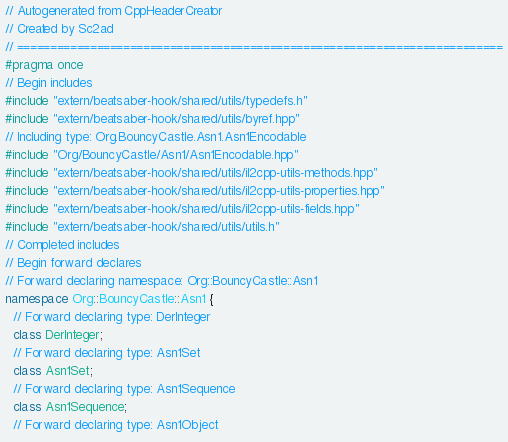Convert code to text. <code><loc_0><loc_0><loc_500><loc_500><_C++_>// Autogenerated from CppHeaderCreator
// Created by Sc2ad
// =========================================================================
#pragma once
// Begin includes
#include "extern/beatsaber-hook/shared/utils/typedefs.h"
#include "extern/beatsaber-hook/shared/utils/byref.hpp"
// Including type: Org.BouncyCastle.Asn1.Asn1Encodable
#include "Org/BouncyCastle/Asn1/Asn1Encodable.hpp"
#include "extern/beatsaber-hook/shared/utils/il2cpp-utils-methods.hpp"
#include "extern/beatsaber-hook/shared/utils/il2cpp-utils-properties.hpp"
#include "extern/beatsaber-hook/shared/utils/il2cpp-utils-fields.hpp"
#include "extern/beatsaber-hook/shared/utils/utils.h"
// Completed includes
// Begin forward declares
// Forward declaring namespace: Org::BouncyCastle::Asn1
namespace Org::BouncyCastle::Asn1 {
  // Forward declaring type: DerInteger
  class DerInteger;
  // Forward declaring type: Asn1Set
  class Asn1Set;
  // Forward declaring type: Asn1Sequence
  class Asn1Sequence;
  // Forward declaring type: Asn1Object</code> 